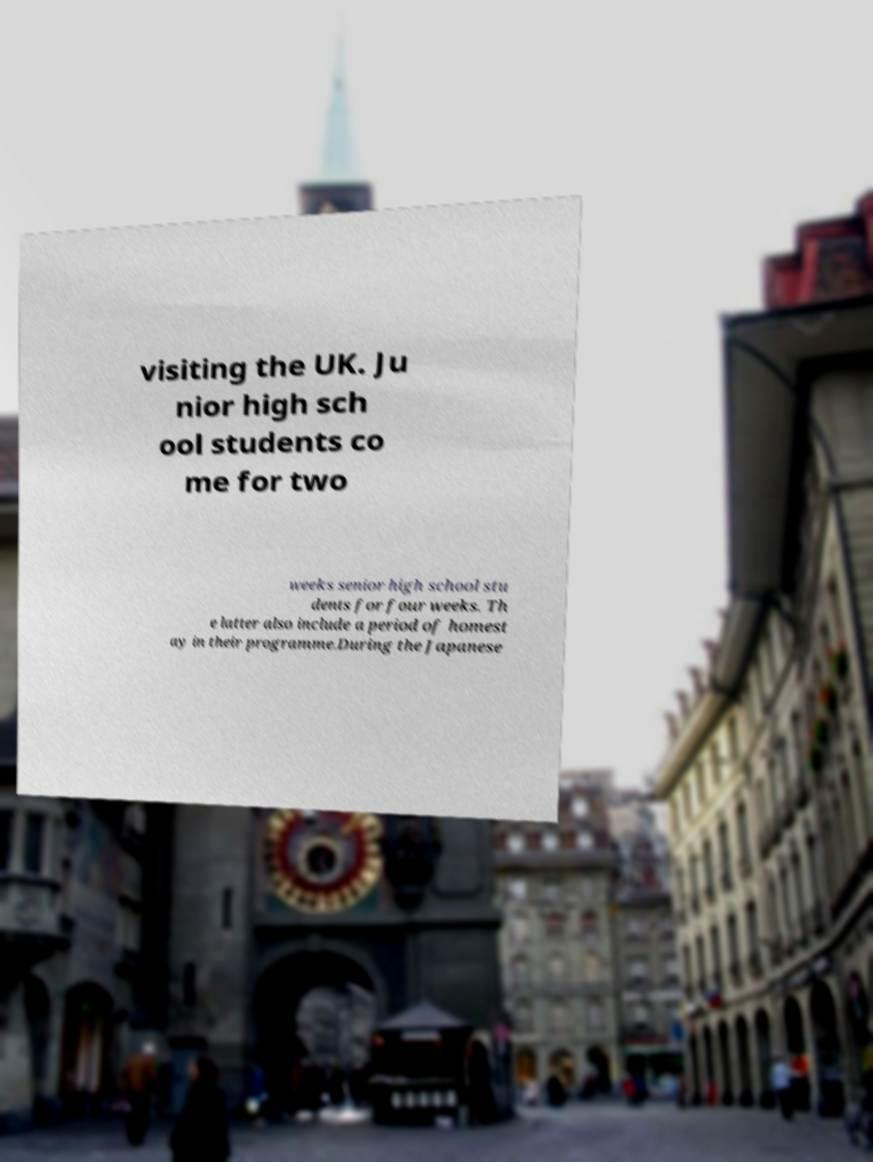Could you extract and type out the text from this image? visiting the UK. Ju nior high sch ool students co me for two weeks senior high school stu dents for four weeks. Th e latter also include a period of homest ay in their programme.During the Japanese 